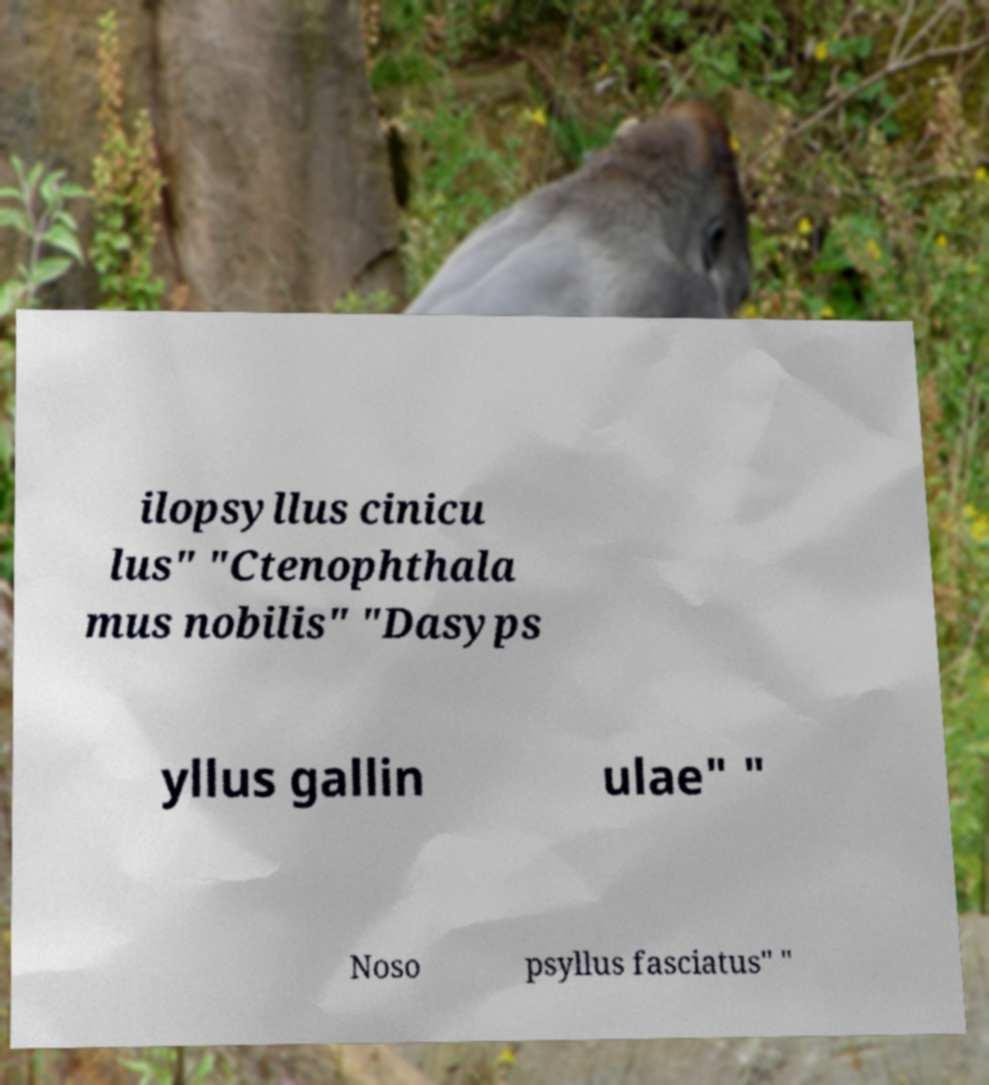Please read and relay the text visible in this image. What does it say? ilopsyllus cinicu lus" "Ctenophthala mus nobilis" "Dasyps yllus gallin ulae" " Noso psyllus fasciatus" " 